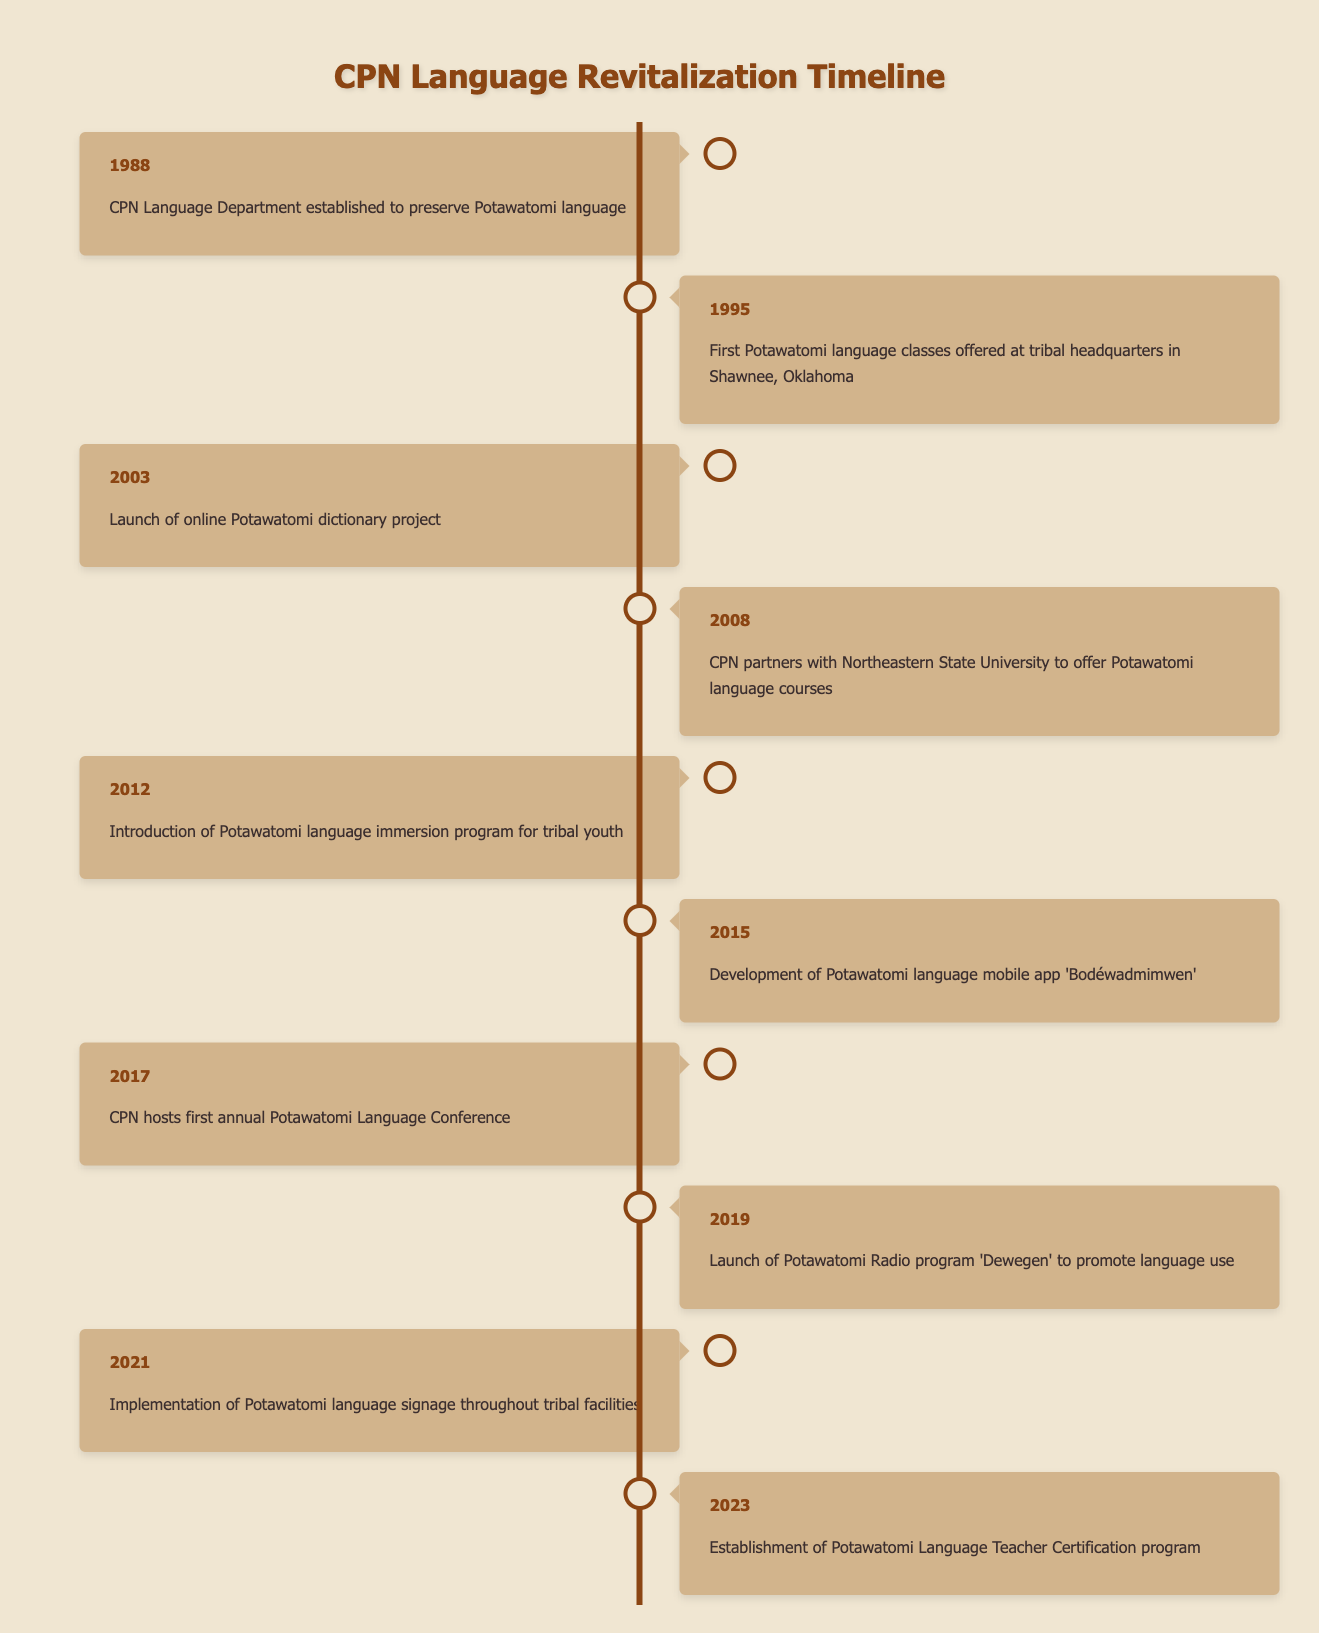What year was the CPN Language Department established? The table indicates that the CPN Language Department was established in 1988.
Answer: 1988 How many language courses or programs were introduced between 2008 and 2023? The table shows two significant events between 2008 and 2023: the partnership with Northeastern State University for language courses in 2008 and the introduction of a language teacher certification program in 2023. Therefore, there are two events related to language courses or programs.
Answer: 2 Was an online Potawatomi dictionary project launched? Yes, the table states that the online Potawatomi dictionary project was launched in 2003.
Answer: Yes What is the difference in years between the establishment of the language department and the introduction of the immersion program? The CPN Language Department was established in 1988 and the immersion program was introduced in 2012. The difference is 2012 - 1988 = 24 years.
Answer: 24 Which event in 2015 is related to mobile technology? In 2015, the development of the Potawatomi language mobile app 'Bodéwadmimwen' is noted, which is related to mobile technology.
Answer: Development of mobile app 'Bodéwadmimwen' What was the primary focus of the first annual Potawatomi Language Conference held in 2017? The table indicates that the focus of the first annual Potawatomi Language Conference was to promote the Potawatomi language, reflecting a commitment to language revitalization efforts.
Answer: Promoting the Potawatomi language In total, how many significant events in language revitalization have occurred from 1988 to 2023? By counting all the milestones listed in the table from 1988 to 2023, there are ten significant events in total: 1) 1988, 2) 1995, 3) 2003, 4) 2008, 5) 2012, 6) 2015, 7) 2017, 8) 2019, 9) 2021, 10) 2023.
Answer: 10 Did the CPN initiate any programs specifically for tribal youth? Yes, the introduction of the Potawatomi language immersion program in 2012 specifically targets tribal youth according to the table.
Answer: Yes What is the chronological order of events regarding language classes starting from 1995 to 2021? The order of events starting from 1995 is: 1) 1995 - First language classes offered, 2) 2008 - Partnership with Northeastern State University, 3) 2012 - Introduction of immersion program, 4) 2021 - Implementation of language signage. The events show a progression in the offering and implementation of language classes.
Answer: 1995, 2008, 2012, 2021 